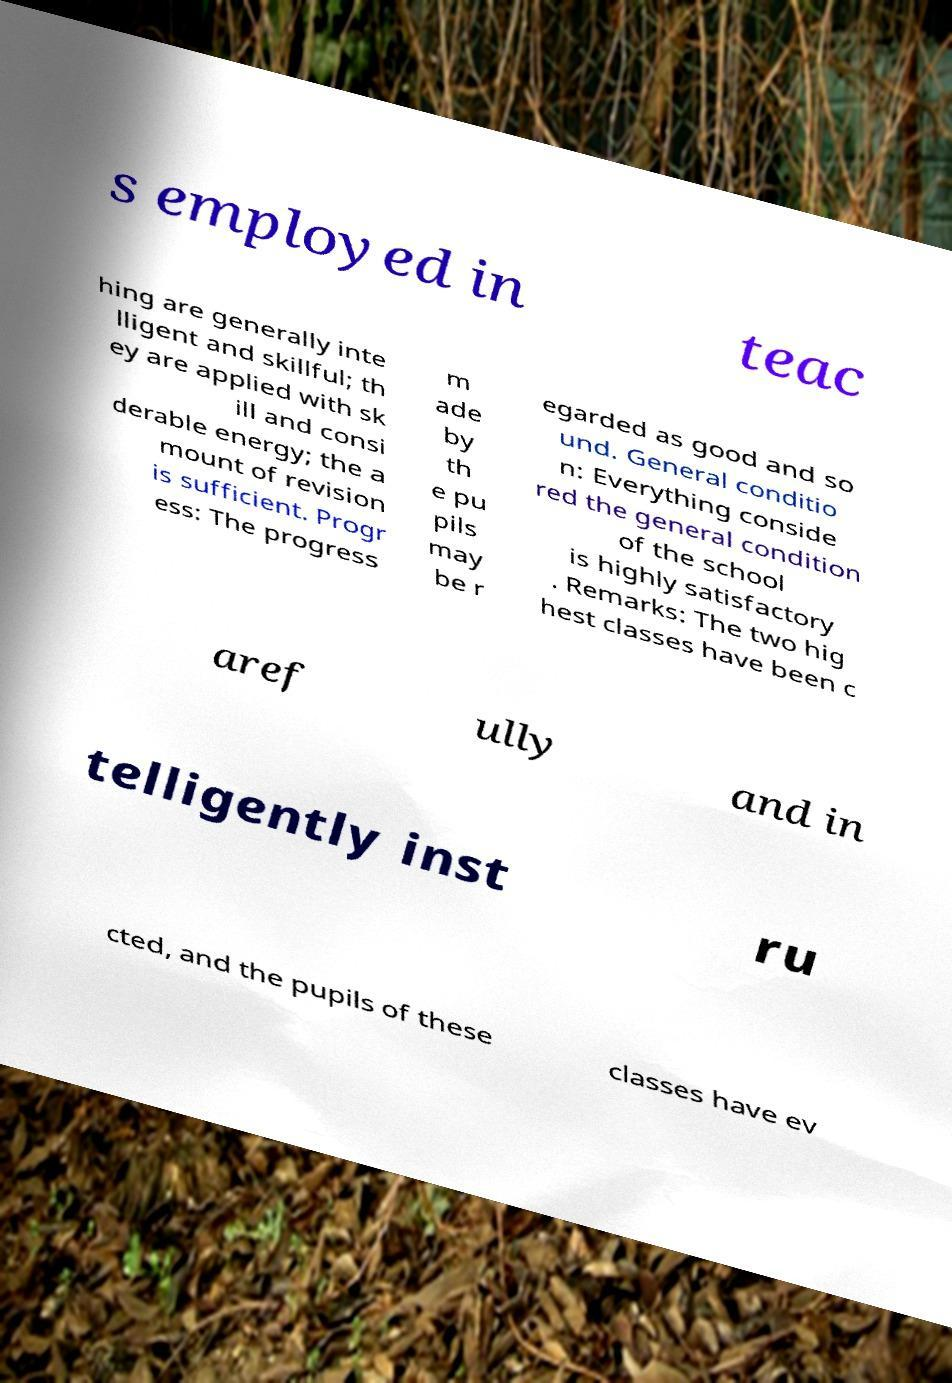Could you assist in decoding the text presented in this image and type it out clearly? s employed in teac hing are generally inte lligent and skillful; th ey are applied with sk ill and consi derable energy; the a mount of revision is sufficient. Progr ess: The progress m ade by th e pu pils may be r egarded as good and so und. General conditio n: Everything conside red the general condition of the school is highly satisfactory . Remarks: The two hig hest classes have been c aref ully and in telligently inst ru cted, and the pupils of these classes have ev 